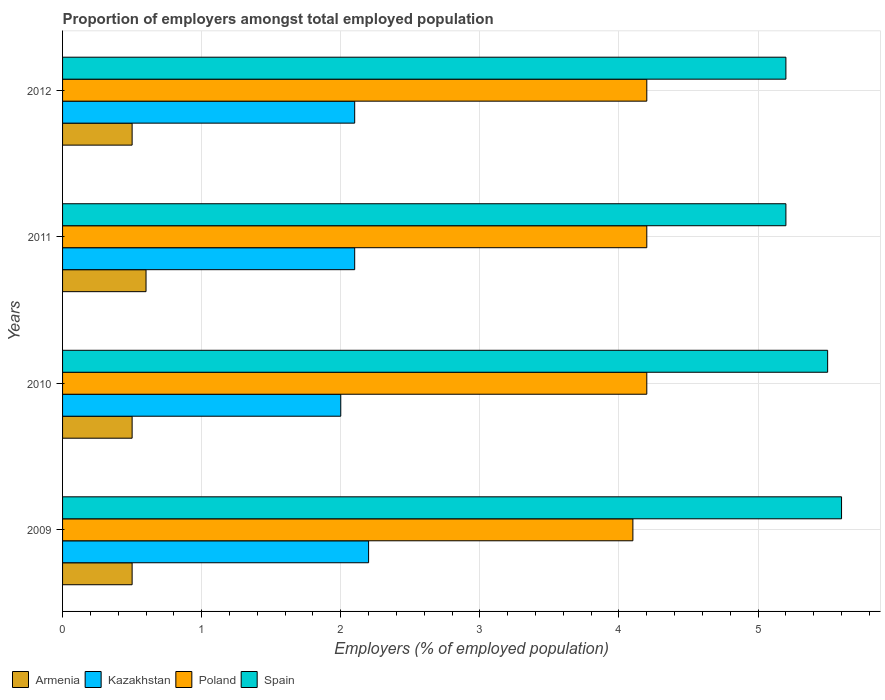Are the number of bars per tick equal to the number of legend labels?
Give a very brief answer. Yes. Are the number of bars on each tick of the Y-axis equal?
Provide a succinct answer. Yes. How many bars are there on the 3rd tick from the top?
Provide a succinct answer. 4. How many bars are there on the 2nd tick from the bottom?
Ensure brevity in your answer.  4. What is the proportion of employers in Kazakhstan in 2010?
Ensure brevity in your answer.  2. Across all years, what is the maximum proportion of employers in Kazakhstan?
Offer a terse response. 2.2. Across all years, what is the minimum proportion of employers in Armenia?
Offer a very short reply. 0.5. In which year was the proportion of employers in Spain minimum?
Your response must be concise. 2011. What is the total proportion of employers in Kazakhstan in the graph?
Your answer should be compact. 8.4. What is the difference between the proportion of employers in Poland in 2009 and that in 2012?
Keep it short and to the point. -0.1. What is the difference between the proportion of employers in Spain in 2010 and the proportion of employers in Kazakhstan in 2009?
Offer a very short reply. 3.3. What is the average proportion of employers in Armenia per year?
Provide a succinct answer. 0.53. In the year 2011, what is the difference between the proportion of employers in Spain and proportion of employers in Armenia?
Provide a succinct answer. 4.6. What is the ratio of the proportion of employers in Poland in 2009 to that in 2010?
Make the answer very short. 0.98. Is the proportion of employers in Kazakhstan in 2010 less than that in 2012?
Make the answer very short. Yes. What is the difference between the highest and the second highest proportion of employers in Armenia?
Your response must be concise. 0.1. What is the difference between the highest and the lowest proportion of employers in Kazakhstan?
Ensure brevity in your answer.  0.2. In how many years, is the proportion of employers in Kazakhstan greater than the average proportion of employers in Kazakhstan taken over all years?
Ensure brevity in your answer.  1. What does the 4th bar from the bottom in 2009 represents?
Your response must be concise. Spain. How many bars are there?
Your answer should be very brief. 16. Are all the bars in the graph horizontal?
Ensure brevity in your answer.  Yes. Are the values on the major ticks of X-axis written in scientific E-notation?
Provide a short and direct response. No. Does the graph contain any zero values?
Offer a terse response. No. Where does the legend appear in the graph?
Provide a short and direct response. Bottom left. What is the title of the graph?
Give a very brief answer. Proportion of employers amongst total employed population. What is the label or title of the X-axis?
Offer a terse response. Employers (% of employed population). What is the label or title of the Y-axis?
Ensure brevity in your answer.  Years. What is the Employers (% of employed population) of Kazakhstan in 2009?
Your answer should be very brief. 2.2. What is the Employers (% of employed population) in Poland in 2009?
Give a very brief answer. 4.1. What is the Employers (% of employed population) in Spain in 2009?
Make the answer very short. 5.6. What is the Employers (% of employed population) of Armenia in 2010?
Your response must be concise. 0.5. What is the Employers (% of employed population) in Kazakhstan in 2010?
Provide a short and direct response. 2. What is the Employers (% of employed population) of Poland in 2010?
Give a very brief answer. 4.2. What is the Employers (% of employed population) of Spain in 2010?
Your answer should be compact. 5.5. What is the Employers (% of employed population) in Armenia in 2011?
Provide a short and direct response. 0.6. What is the Employers (% of employed population) in Kazakhstan in 2011?
Keep it short and to the point. 2.1. What is the Employers (% of employed population) in Poland in 2011?
Offer a very short reply. 4.2. What is the Employers (% of employed population) of Spain in 2011?
Offer a terse response. 5.2. What is the Employers (% of employed population) in Armenia in 2012?
Offer a terse response. 0.5. What is the Employers (% of employed population) in Kazakhstan in 2012?
Give a very brief answer. 2.1. What is the Employers (% of employed population) of Poland in 2012?
Your answer should be very brief. 4.2. What is the Employers (% of employed population) in Spain in 2012?
Offer a terse response. 5.2. Across all years, what is the maximum Employers (% of employed population) in Armenia?
Give a very brief answer. 0.6. Across all years, what is the maximum Employers (% of employed population) of Kazakhstan?
Your answer should be very brief. 2.2. Across all years, what is the maximum Employers (% of employed population) in Poland?
Your answer should be compact. 4.2. Across all years, what is the maximum Employers (% of employed population) of Spain?
Provide a succinct answer. 5.6. Across all years, what is the minimum Employers (% of employed population) in Kazakhstan?
Your response must be concise. 2. Across all years, what is the minimum Employers (% of employed population) of Poland?
Keep it short and to the point. 4.1. Across all years, what is the minimum Employers (% of employed population) in Spain?
Give a very brief answer. 5.2. What is the total Employers (% of employed population) of Poland in the graph?
Provide a succinct answer. 16.7. What is the difference between the Employers (% of employed population) of Armenia in 2009 and that in 2010?
Your answer should be compact. 0. What is the difference between the Employers (% of employed population) in Kazakhstan in 2009 and that in 2010?
Make the answer very short. 0.2. What is the difference between the Employers (% of employed population) of Poland in 2009 and that in 2010?
Offer a terse response. -0.1. What is the difference between the Employers (% of employed population) of Armenia in 2009 and that in 2011?
Your answer should be very brief. -0.1. What is the difference between the Employers (% of employed population) in Armenia in 2009 and that in 2012?
Provide a short and direct response. 0. What is the difference between the Employers (% of employed population) of Kazakhstan in 2009 and that in 2012?
Provide a short and direct response. 0.1. What is the difference between the Employers (% of employed population) in Spain in 2009 and that in 2012?
Ensure brevity in your answer.  0.4. What is the difference between the Employers (% of employed population) of Armenia in 2010 and that in 2011?
Provide a succinct answer. -0.1. What is the difference between the Employers (% of employed population) of Kazakhstan in 2010 and that in 2011?
Offer a very short reply. -0.1. What is the difference between the Employers (% of employed population) of Spain in 2010 and that in 2011?
Give a very brief answer. 0.3. What is the difference between the Employers (% of employed population) in Armenia in 2011 and that in 2012?
Give a very brief answer. 0.1. What is the difference between the Employers (% of employed population) of Kazakhstan in 2011 and that in 2012?
Provide a succinct answer. 0. What is the difference between the Employers (% of employed population) in Spain in 2011 and that in 2012?
Give a very brief answer. 0. What is the difference between the Employers (% of employed population) in Armenia in 2009 and the Employers (% of employed population) in Poland in 2010?
Ensure brevity in your answer.  -3.7. What is the difference between the Employers (% of employed population) of Poland in 2009 and the Employers (% of employed population) of Spain in 2010?
Offer a very short reply. -1.4. What is the difference between the Employers (% of employed population) in Armenia in 2009 and the Employers (% of employed population) in Kazakhstan in 2011?
Ensure brevity in your answer.  -1.6. What is the difference between the Employers (% of employed population) of Armenia in 2009 and the Employers (% of employed population) of Poland in 2011?
Give a very brief answer. -3.7. What is the difference between the Employers (% of employed population) of Kazakhstan in 2009 and the Employers (% of employed population) of Spain in 2011?
Your answer should be compact. -3. What is the difference between the Employers (% of employed population) in Armenia in 2009 and the Employers (% of employed population) in Kazakhstan in 2012?
Provide a succinct answer. -1.6. What is the difference between the Employers (% of employed population) in Armenia in 2009 and the Employers (% of employed population) in Poland in 2012?
Ensure brevity in your answer.  -3.7. What is the difference between the Employers (% of employed population) of Kazakhstan in 2009 and the Employers (% of employed population) of Poland in 2012?
Your response must be concise. -2. What is the difference between the Employers (% of employed population) in Kazakhstan in 2009 and the Employers (% of employed population) in Spain in 2012?
Offer a terse response. -3. What is the difference between the Employers (% of employed population) of Poland in 2009 and the Employers (% of employed population) of Spain in 2012?
Your answer should be very brief. -1.1. What is the difference between the Employers (% of employed population) in Armenia in 2010 and the Employers (% of employed population) in Kazakhstan in 2011?
Offer a very short reply. -1.6. What is the difference between the Employers (% of employed population) in Armenia in 2010 and the Employers (% of employed population) in Poland in 2011?
Provide a short and direct response. -3.7. What is the difference between the Employers (% of employed population) in Kazakhstan in 2010 and the Employers (% of employed population) in Poland in 2011?
Give a very brief answer. -2.2. What is the difference between the Employers (% of employed population) in Poland in 2010 and the Employers (% of employed population) in Spain in 2011?
Provide a short and direct response. -1. What is the difference between the Employers (% of employed population) in Armenia in 2010 and the Employers (% of employed population) in Kazakhstan in 2012?
Give a very brief answer. -1.6. What is the difference between the Employers (% of employed population) of Armenia in 2010 and the Employers (% of employed population) of Poland in 2012?
Give a very brief answer. -3.7. What is the difference between the Employers (% of employed population) of Kazakhstan in 2010 and the Employers (% of employed population) of Poland in 2012?
Your answer should be very brief. -2.2. What is the difference between the Employers (% of employed population) of Armenia in 2011 and the Employers (% of employed population) of Kazakhstan in 2012?
Keep it short and to the point. -1.5. What is the difference between the Employers (% of employed population) in Armenia in 2011 and the Employers (% of employed population) in Poland in 2012?
Your answer should be very brief. -3.6. What is the difference between the Employers (% of employed population) of Kazakhstan in 2011 and the Employers (% of employed population) of Poland in 2012?
Give a very brief answer. -2.1. What is the difference between the Employers (% of employed population) in Poland in 2011 and the Employers (% of employed population) in Spain in 2012?
Provide a succinct answer. -1. What is the average Employers (% of employed population) in Armenia per year?
Offer a terse response. 0.53. What is the average Employers (% of employed population) in Kazakhstan per year?
Provide a short and direct response. 2.1. What is the average Employers (% of employed population) in Poland per year?
Your answer should be very brief. 4.17. What is the average Employers (% of employed population) in Spain per year?
Offer a very short reply. 5.38. In the year 2009, what is the difference between the Employers (% of employed population) in Kazakhstan and Employers (% of employed population) in Poland?
Keep it short and to the point. -1.9. In the year 2009, what is the difference between the Employers (% of employed population) of Kazakhstan and Employers (% of employed population) of Spain?
Make the answer very short. -3.4. In the year 2009, what is the difference between the Employers (% of employed population) of Poland and Employers (% of employed population) of Spain?
Make the answer very short. -1.5. In the year 2010, what is the difference between the Employers (% of employed population) in Armenia and Employers (% of employed population) in Kazakhstan?
Keep it short and to the point. -1.5. In the year 2010, what is the difference between the Employers (% of employed population) in Armenia and Employers (% of employed population) in Spain?
Offer a very short reply. -5. In the year 2010, what is the difference between the Employers (% of employed population) of Kazakhstan and Employers (% of employed population) of Poland?
Your response must be concise. -2.2. In the year 2010, what is the difference between the Employers (% of employed population) in Kazakhstan and Employers (% of employed population) in Spain?
Ensure brevity in your answer.  -3.5. In the year 2011, what is the difference between the Employers (% of employed population) of Armenia and Employers (% of employed population) of Kazakhstan?
Offer a terse response. -1.5. In the year 2011, what is the difference between the Employers (% of employed population) of Armenia and Employers (% of employed population) of Poland?
Make the answer very short. -3.6. In the year 2011, what is the difference between the Employers (% of employed population) of Kazakhstan and Employers (% of employed population) of Spain?
Keep it short and to the point. -3.1. In the year 2011, what is the difference between the Employers (% of employed population) in Poland and Employers (% of employed population) in Spain?
Your response must be concise. -1. In the year 2012, what is the difference between the Employers (% of employed population) of Armenia and Employers (% of employed population) of Kazakhstan?
Ensure brevity in your answer.  -1.6. In the year 2012, what is the difference between the Employers (% of employed population) in Kazakhstan and Employers (% of employed population) in Spain?
Ensure brevity in your answer.  -3.1. What is the ratio of the Employers (% of employed population) of Armenia in 2009 to that in 2010?
Provide a succinct answer. 1. What is the ratio of the Employers (% of employed population) of Poland in 2009 to that in 2010?
Give a very brief answer. 0.98. What is the ratio of the Employers (% of employed population) in Spain in 2009 to that in 2010?
Provide a short and direct response. 1.02. What is the ratio of the Employers (% of employed population) of Kazakhstan in 2009 to that in 2011?
Provide a short and direct response. 1.05. What is the ratio of the Employers (% of employed population) in Poland in 2009 to that in 2011?
Offer a very short reply. 0.98. What is the ratio of the Employers (% of employed population) in Spain in 2009 to that in 2011?
Your answer should be compact. 1.08. What is the ratio of the Employers (% of employed population) of Armenia in 2009 to that in 2012?
Keep it short and to the point. 1. What is the ratio of the Employers (% of employed population) in Kazakhstan in 2009 to that in 2012?
Your answer should be compact. 1.05. What is the ratio of the Employers (% of employed population) of Poland in 2009 to that in 2012?
Your answer should be compact. 0.98. What is the ratio of the Employers (% of employed population) in Spain in 2009 to that in 2012?
Offer a terse response. 1.08. What is the ratio of the Employers (% of employed population) in Kazakhstan in 2010 to that in 2011?
Your response must be concise. 0.95. What is the ratio of the Employers (% of employed population) in Poland in 2010 to that in 2011?
Offer a very short reply. 1. What is the ratio of the Employers (% of employed population) of Spain in 2010 to that in 2011?
Make the answer very short. 1.06. What is the ratio of the Employers (% of employed population) in Armenia in 2010 to that in 2012?
Offer a very short reply. 1. What is the ratio of the Employers (% of employed population) of Poland in 2010 to that in 2012?
Your response must be concise. 1. What is the ratio of the Employers (% of employed population) of Spain in 2010 to that in 2012?
Keep it short and to the point. 1.06. What is the ratio of the Employers (% of employed population) in Kazakhstan in 2011 to that in 2012?
Offer a very short reply. 1. What is the difference between the highest and the second highest Employers (% of employed population) of Armenia?
Provide a succinct answer. 0.1. What is the difference between the highest and the second highest Employers (% of employed population) in Poland?
Provide a succinct answer. 0. What is the difference between the highest and the second highest Employers (% of employed population) of Spain?
Your response must be concise. 0.1. What is the difference between the highest and the lowest Employers (% of employed population) in Poland?
Provide a succinct answer. 0.1. What is the difference between the highest and the lowest Employers (% of employed population) in Spain?
Keep it short and to the point. 0.4. 